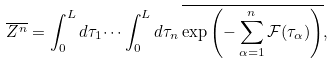<formula> <loc_0><loc_0><loc_500><loc_500>\overline { Z ^ { n } } = \int _ { 0 } ^ { L } d \tau _ { 1 } \dots \int _ { 0 } ^ { L } d \tau _ { n } \, \overline { \exp \left ( - \sum _ { \alpha = 1 } ^ { n } \mathcal { F } ( \tau _ { \alpha } ) \right ) } ,</formula> 